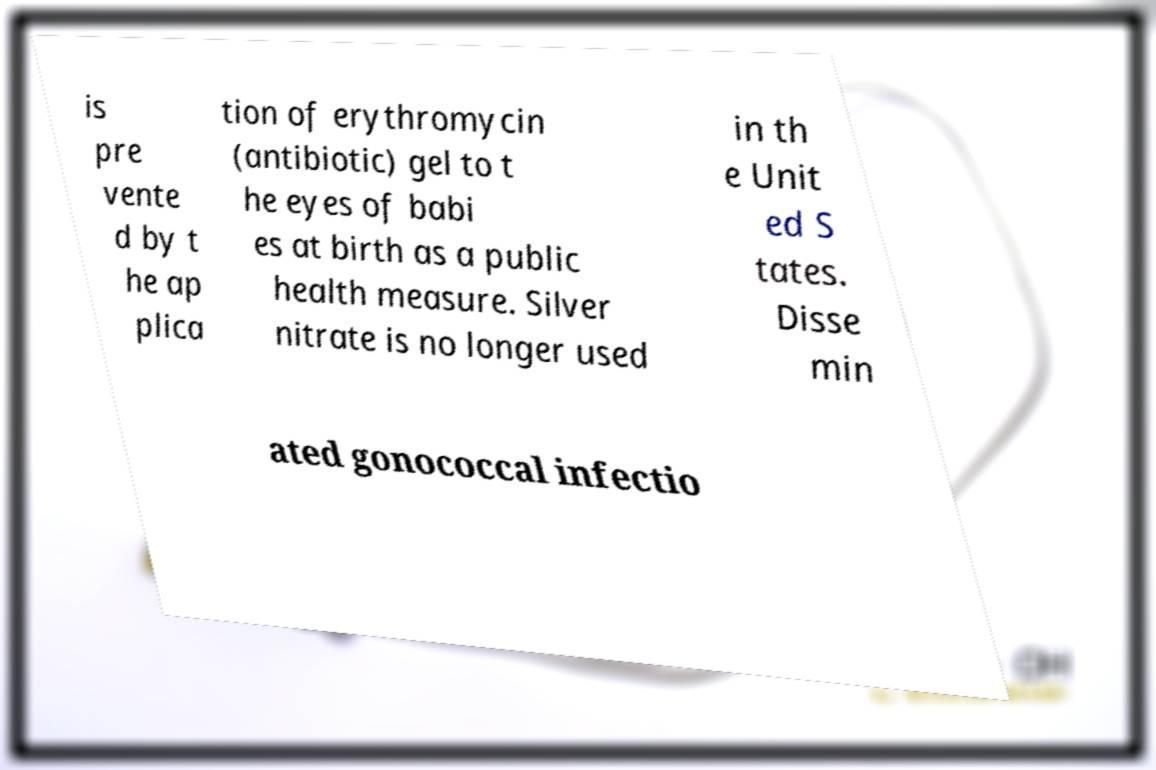There's text embedded in this image that I need extracted. Can you transcribe it verbatim? is pre vente d by t he ap plica tion of erythromycin (antibiotic) gel to t he eyes of babi es at birth as a public health measure. Silver nitrate is no longer used in th e Unit ed S tates. Disse min ated gonococcal infectio 